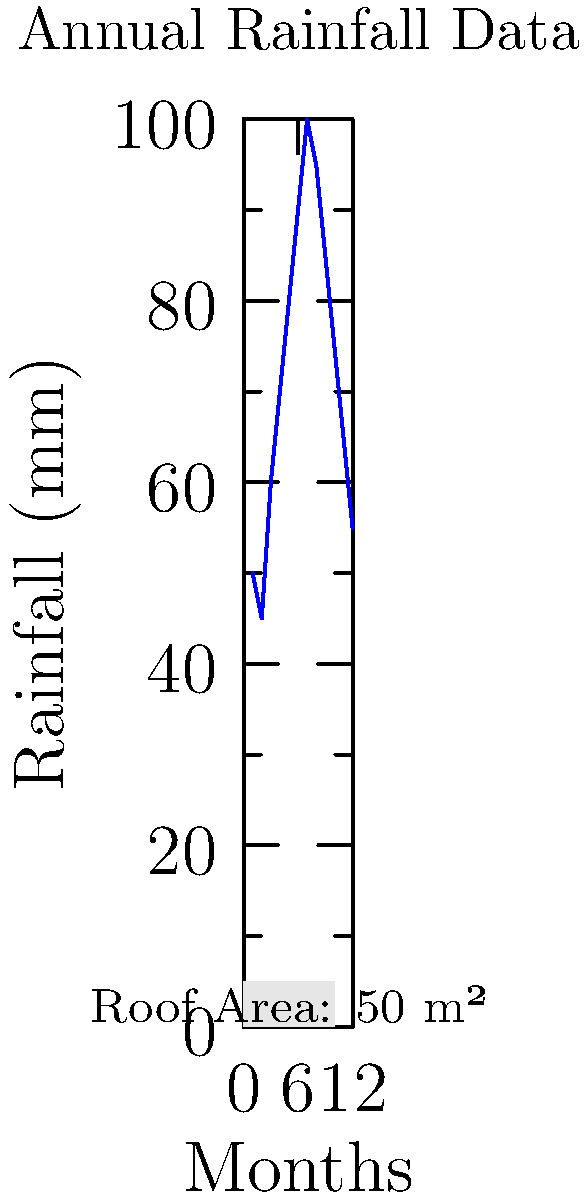Given a building with a roof area of 50 m² and the annual rainfall data shown in the graph, calculate the total volume of rainwater that could be harvested in a year. Assume a collection efficiency of 80% due to factors such as evaporation and system losses. To calculate the total volume of rainwater that can be harvested, we'll follow these steps:

1. Calculate the total annual rainfall:
   Sum of monthly rainfall = 50 + 45 + 60 + 70 + 80 + 90 + 100 + 95 + 85 + 75 + 65 + 55 = 870 mm

2. Convert rainfall from mm to meters:
   870 mm = 0.87 m

3. Calculate the total volume of water falling on the roof:
   Volume = Roof Area × Annual Rainfall
   $V = 50 \text{ m}^2 \times 0.87 \text{ m} = 43.5 \text{ m}^3$

4. Apply the collection efficiency:
   Harvested Volume = Total Volume × Efficiency
   $V_{harvested} = 43.5 \text{ m}^3 \times 0.80 = 34.8 \text{ m}^3$

Therefore, the total volume of rainwater that could be harvested in a year is 34.8 m³.
Answer: 34.8 m³ 